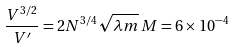<formula> <loc_0><loc_0><loc_500><loc_500>\frac { V ^ { 3 / 2 } } { V ^ { \prime } } = 2 N ^ { 3 / 4 } \sqrt { \lambda m } \, M = 6 \times 1 0 ^ { - 4 }</formula> 